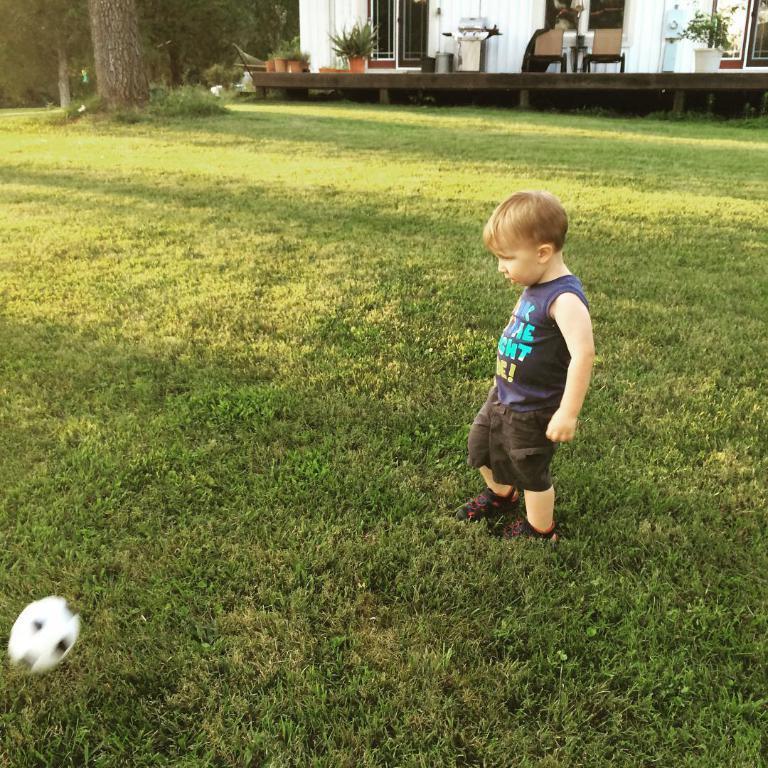Describe this image in one or two sentences. In the center of the image we can see one kid is standing. In the bottom left side of the image, we can see one ball. In the background, we can see trees, one building, glass doors, chairs, plant pots, plants, grass and a few other objects. 